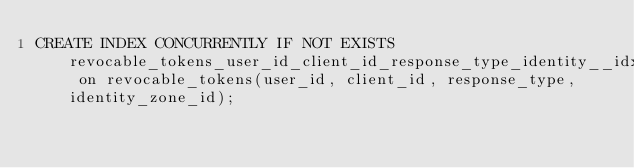Convert code to text. <code><loc_0><loc_0><loc_500><loc_500><_SQL_>CREATE INDEX CONCURRENTLY IF NOT EXISTS revocable_tokens_user_id_client_id_response_type_identity__idx on revocable_tokens(user_id, client_id, response_type, identity_zone_id);
</code> 